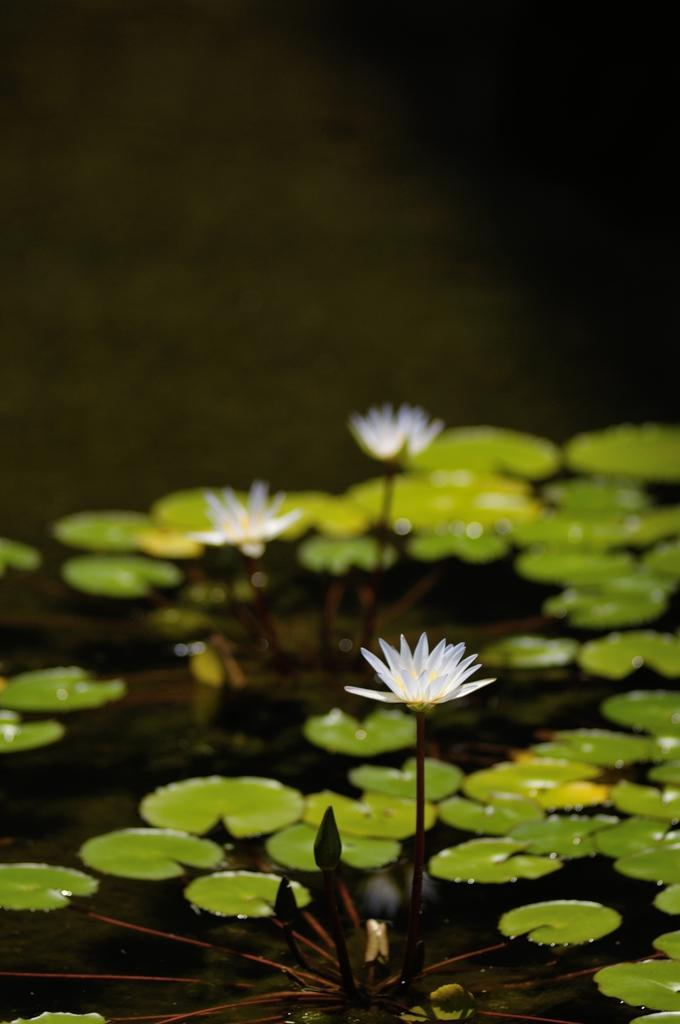What is floating on the surface of the water in the image? There are leaves and flowers on the surface of the water in the image. Can you describe the appearance of the leaves and flowers? The leaves and flowers appear to be floating on the water's surface. How many times has the wish been granted in the image? There is no mention of a wish in the image, so it cannot be determined how many times it has been granted. 